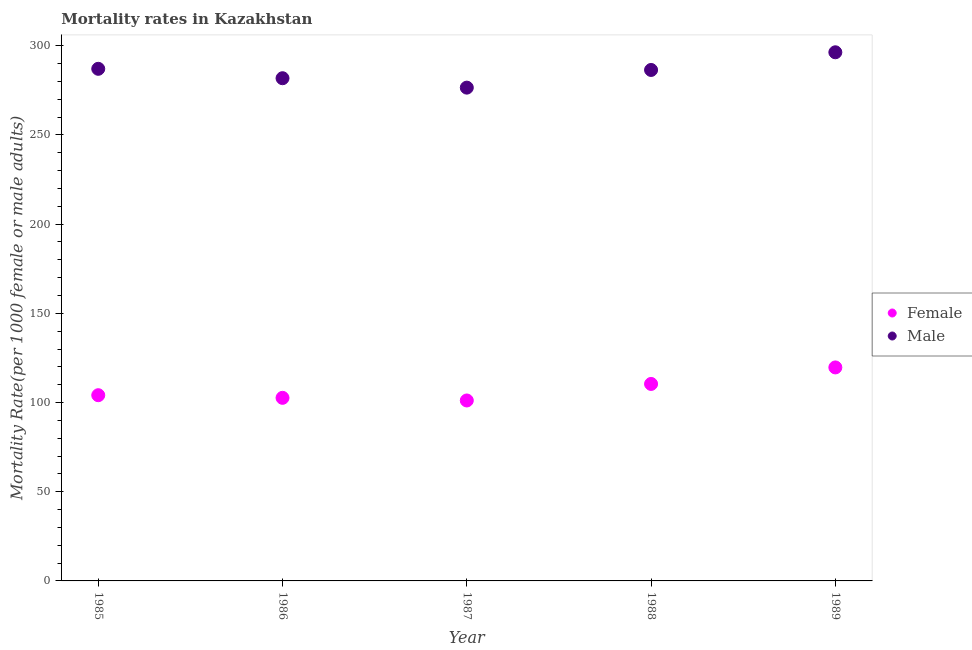How many different coloured dotlines are there?
Your response must be concise. 2. What is the female mortality rate in 1987?
Offer a very short reply. 101.16. Across all years, what is the maximum male mortality rate?
Give a very brief answer. 296.34. Across all years, what is the minimum male mortality rate?
Offer a terse response. 276.53. In which year was the male mortality rate minimum?
Ensure brevity in your answer.  1987. What is the total male mortality rate in the graph?
Make the answer very short. 1428.19. What is the difference between the male mortality rate in 1986 and that in 1987?
Provide a succinct answer. 5.27. What is the difference between the male mortality rate in 1985 and the female mortality rate in 1988?
Your answer should be very brief. 176.66. What is the average male mortality rate per year?
Your answer should be compact. 285.64. In the year 1988, what is the difference between the male mortality rate and female mortality rate?
Keep it short and to the point. 176.02. In how many years, is the female mortality rate greater than 210?
Provide a short and direct response. 0. What is the ratio of the female mortality rate in 1986 to that in 1988?
Offer a terse response. 0.93. Is the female mortality rate in 1986 less than that in 1989?
Give a very brief answer. Yes. Is the difference between the male mortality rate in 1988 and 1989 greater than the difference between the female mortality rate in 1988 and 1989?
Your response must be concise. No. What is the difference between the highest and the second highest male mortality rate?
Offer a very short reply. 9.27. What is the difference between the highest and the lowest female mortality rate?
Your answer should be compact. 18.53. In how many years, is the female mortality rate greater than the average female mortality rate taken over all years?
Your answer should be compact. 2. Is the sum of the female mortality rate in 1986 and 1989 greater than the maximum male mortality rate across all years?
Offer a terse response. No. Does the female mortality rate monotonically increase over the years?
Your response must be concise. No. Is the female mortality rate strictly less than the male mortality rate over the years?
Offer a very short reply. Yes. What is the difference between two consecutive major ticks on the Y-axis?
Keep it short and to the point. 50. Does the graph contain any zero values?
Offer a terse response. No. Does the graph contain grids?
Your response must be concise. No. Where does the legend appear in the graph?
Offer a terse response. Center right. How many legend labels are there?
Provide a succinct answer. 2. What is the title of the graph?
Your answer should be compact. Mortality rates in Kazakhstan. Does "Primary income" appear as one of the legend labels in the graph?
Your response must be concise. No. What is the label or title of the X-axis?
Ensure brevity in your answer.  Year. What is the label or title of the Y-axis?
Keep it short and to the point. Mortality Rate(per 1000 female or male adults). What is the Mortality Rate(per 1000 female or male adults) in Female in 1985?
Provide a succinct answer. 104.11. What is the Mortality Rate(per 1000 female or male adults) in Male in 1985?
Your answer should be very brief. 287.08. What is the Mortality Rate(per 1000 female or male adults) in Female in 1986?
Offer a terse response. 102.63. What is the Mortality Rate(per 1000 female or male adults) of Male in 1986?
Your answer should be very brief. 281.8. What is the Mortality Rate(per 1000 female or male adults) of Female in 1987?
Your response must be concise. 101.16. What is the Mortality Rate(per 1000 female or male adults) of Male in 1987?
Your answer should be very brief. 276.53. What is the Mortality Rate(per 1000 female or male adults) in Female in 1988?
Your answer should be compact. 110.42. What is the Mortality Rate(per 1000 female or male adults) in Male in 1988?
Your answer should be compact. 286.44. What is the Mortality Rate(per 1000 female or male adults) in Female in 1989?
Keep it short and to the point. 119.68. What is the Mortality Rate(per 1000 female or male adults) in Male in 1989?
Provide a succinct answer. 296.34. Across all years, what is the maximum Mortality Rate(per 1000 female or male adults) in Female?
Your answer should be very brief. 119.68. Across all years, what is the maximum Mortality Rate(per 1000 female or male adults) of Male?
Your response must be concise. 296.34. Across all years, what is the minimum Mortality Rate(per 1000 female or male adults) of Female?
Offer a terse response. 101.16. Across all years, what is the minimum Mortality Rate(per 1000 female or male adults) in Male?
Provide a short and direct response. 276.53. What is the total Mortality Rate(per 1000 female or male adults) in Female in the graph?
Keep it short and to the point. 538. What is the total Mortality Rate(per 1000 female or male adults) in Male in the graph?
Your response must be concise. 1428.19. What is the difference between the Mortality Rate(per 1000 female or male adults) of Female in 1985 and that in 1986?
Your answer should be compact. 1.48. What is the difference between the Mortality Rate(per 1000 female or male adults) in Male in 1985 and that in 1986?
Offer a terse response. 5.28. What is the difference between the Mortality Rate(per 1000 female or male adults) of Female in 1985 and that in 1987?
Your answer should be very brief. 2.96. What is the difference between the Mortality Rate(per 1000 female or male adults) in Male in 1985 and that in 1987?
Keep it short and to the point. 10.55. What is the difference between the Mortality Rate(per 1000 female or male adults) of Female in 1985 and that in 1988?
Offer a terse response. -6.31. What is the difference between the Mortality Rate(per 1000 female or male adults) of Male in 1985 and that in 1988?
Your answer should be very brief. 0.64. What is the difference between the Mortality Rate(per 1000 female or male adults) in Female in 1985 and that in 1989?
Provide a short and direct response. -15.57. What is the difference between the Mortality Rate(per 1000 female or male adults) of Male in 1985 and that in 1989?
Give a very brief answer. -9.27. What is the difference between the Mortality Rate(per 1000 female or male adults) of Female in 1986 and that in 1987?
Give a very brief answer. 1.48. What is the difference between the Mortality Rate(per 1000 female or male adults) of Male in 1986 and that in 1987?
Your answer should be very brief. 5.28. What is the difference between the Mortality Rate(per 1000 female or male adults) in Female in 1986 and that in 1988?
Provide a short and direct response. -7.79. What is the difference between the Mortality Rate(per 1000 female or male adults) of Male in 1986 and that in 1988?
Offer a terse response. -4.63. What is the difference between the Mortality Rate(per 1000 female or male adults) of Female in 1986 and that in 1989?
Provide a short and direct response. -17.05. What is the difference between the Mortality Rate(per 1000 female or male adults) in Male in 1986 and that in 1989?
Provide a short and direct response. -14.54. What is the difference between the Mortality Rate(per 1000 female or male adults) in Female in 1987 and that in 1988?
Make the answer very short. -9.26. What is the difference between the Mortality Rate(per 1000 female or male adults) of Male in 1987 and that in 1988?
Ensure brevity in your answer.  -9.91. What is the difference between the Mortality Rate(per 1000 female or male adults) of Female in 1987 and that in 1989?
Keep it short and to the point. -18.53. What is the difference between the Mortality Rate(per 1000 female or male adults) in Male in 1987 and that in 1989?
Provide a succinct answer. -19.82. What is the difference between the Mortality Rate(per 1000 female or male adults) in Female in 1988 and that in 1989?
Give a very brief answer. -9.26. What is the difference between the Mortality Rate(per 1000 female or male adults) in Male in 1988 and that in 1989?
Ensure brevity in your answer.  -9.91. What is the difference between the Mortality Rate(per 1000 female or male adults) of Female in 1985 and the Mortality Rate(per 1000 female or male adults) of Male in 1986?
Provide a short and direct response. -177.69. What is the difference between the Mortality Rate(per 1000 female or male adults) in Female in 1985 and the Mortality Rate(per 1000 female or male adults) in Male in 1987?
Your answer should be compact. -172.42. What is the difference between the Mortality Rate(per 1000 female or male adults) in Female in 1985 and the Mortality Rate(per 1000 female or male adults) in Male in 1988?
Provide a succinct answer. -182.32. What is the difference between the Mortality Rate(per 1000 female or male adults) in Female in 1985 and the Mortality Rate(per 1000 female or male adults) in Male in 1989?
Your answer should be compact. -192.23. What is the difference between the Mortality Rate(per 1000 female or male adults) in Female in 1986 and the Mortality Rate(per 1000 female or male adults) in Male in 1987?
Offer a terse response. -173.89. What is the difference between the Mortality Rate(per 1000 female or male adults) of Female in 1986 and the Mortality Rate(per 1000 female or male adults) of Male in 1988?
Your answer should be very brief. -183.8. What is the difference between the Mortality Rate(per 1000 female or male adults) of Female in 1986 and the Mortality Rate(per 1000 female or male adults) of Male in 1989?
Keep it short and to the point. -193.71. What is the difference between the Mortality Rate(per 1000 female or male adults) of Female in 1987 and the Mortality Rate(per 1000 female or male adults) of Male in 1988?
Offer a terse response. -185.28. What is the difference between the Mortality Rate(per 1000 female or male adults) in Female in 1987 and the Mortality Rate(per 1000 female or male adults) in Male in 1989?
Give a very brief answer. -195.19. What is the difference between the Mortality Rate(per 1000 female or male adults) in Female in 1988 and the Mortality Rate(per 1000 female or male adults) in Male in 1989?
Your answer should be very brief. -185.92. What is the average Mortality Rate(per 1000 female or male adults) in Female per year?
Make the answer very short. 107.6. What is the average Mortality Rate(per 1000 female or male adults) in Male per year?
Provide a short and direct response. 285.64. In the year 1985, what is the difference between the Mortality Rate(per 1000 female or male adults) in Female and Mortality Rate(per 1000 female or male adults) in Male?
Keep it short and to the point. -182.97. In the year 1986, what is the difference between the Mortality Rate(per 1000 female or male adults) in Female and Mortality Rate(per 1000 female or male adults) in Male?
Your answer should be very brief. -179.17. In the year 1987, what is the difference between the Mortality Rate(per 1000 female or male adults) of Female and Mortality Rate(per 1000 female or male adults) of Male?
Offer a very short reply. -175.37. In the year 1988, what is the difference between the Mortality Rate(per 1000 female or male adults) of Female and Mortality Rate(per 1000 female or male adults) of Male?
Your answer should be very brief. -176.02. In the year 1989, what is the difference between the Mortality Rate(per 1000 female or male adults) of Female and Mortality Rate(per 1000 female or male adults) of Male?
Provide a succinct answer. -176.66. What is the ratio of the Mortality Rate(per 1000 female or male adults) of Female in 1985 to that in 1986?
Make the answer very short. 1.01. What is the ratio of the Mortality Rate(per 1000 female or male adults) in Male in 1985 to that in 1986?
Keep it short and to the point. 1.02. What is the ratio of the Mortality Rate(per 1000 female or male adults) in Female in 1985 to that in 1987?
Provide a short and direct response. 1.03. What is the ratio of the Mortality Rate(per 1000 female or male adults) of Male in 1985 to that in 1987?
Provide a short and direct response. 1.04. What is the ratio of the Mortality Rate(per 1000 female or male adults) in Female in 1985 to that in 1988?
Provide a succinct answer. 0.94. What is the ratio of the Mortality Rate(per 1000 female or male adults) in Male in 1985 to that in 1988?
Your answer should be compact. 1. What is the ratio of the Mortality Rate(per 1000 female or male adults) of Female in 1985 to that in 1989?
Offer a terse response. 0.87. What is the ratio of the Mortality Rate(per 1000 female or male adults) of Male in 1985 to that in 1989?
Your answer should be very brief. 0.97. What is the ratio of the Mortality Rate(per 1000 female or male adults) of Female in 1986 to that in 1987?
Your answer should be very brief. 1.01. What is the ratio of the Mortality Rate(per 1000 female or male adults) of Male in 1986 to that in 1987?
Your answer should be very brief. 1.02. What is the ratio of the Mortality Rate(per 1000 female or male adults) of Female in 1986 to that in 1988?
Offer a terse response. 0.93. What is the ratio of the Mortality Rate(per 1000 female or male adults) in Male in 1986 to that in 1988?
Ensure brevity in your answer.  0.98. What is the ratio of the Mortality Rate(per 1000 female or male adults) of Female in 1986 to that in 1989?
Provide a short and direct response. 0.86. What is the ratio of the Mortality Rate(per 1000 female or male adults) of Male in 1986 to that in 1989?
Your answer should be compact. 0.95. What is the ratio of the Mortality Rate(per 1000 female or male adults) of Female in 1987 to that in 1988?
Offer a very short reply. 0.92. What is the ratio of the Mortality Rate(per 1000 female or male adults) in Male in 1987 to that in 1988?
Ensure brevity in your answer.  0.97. What is the ratio of the Mortality Rate(per 1000 female or male adults) of Female in 1987 to that in 1989?
Your answer should be very brief. 0.85. What is the ratio of the Mortality Rate(per 1000 female or male adults) of Male in 1987 to that in 1989?
Keep it short and to the point. 0.93. What is the ratio of the Mortality Rate(per 1000 female or male adults) in Female in 1988 to that in 1989?
Offer a very short reply. 0.92. What is the ratio of the Mortality Rate(per 1000 female or male adults) in Male in 1988 to that in 1989?
Your response must be concise. 0.97. What is the difference between the highest and the second highest Mortality Rate(per 1000 female or male adults) in Female?
Offer a very short reply. 9.26. What is the difference between the highest and the second highest Mortality Rate(per 1000 female or male adults) in Male?
Keep it short and to the point. 9.27. What is the difference between the highest and the lowest Mortality Rate(per 1000 female or male adults) of Female?
Make the answer very short. 18.53. What is the difference between the highest and the lowest Mortality Rate(per 1000 female or male adults) in Male?
Ensure brevity in your answer.  19.82. 